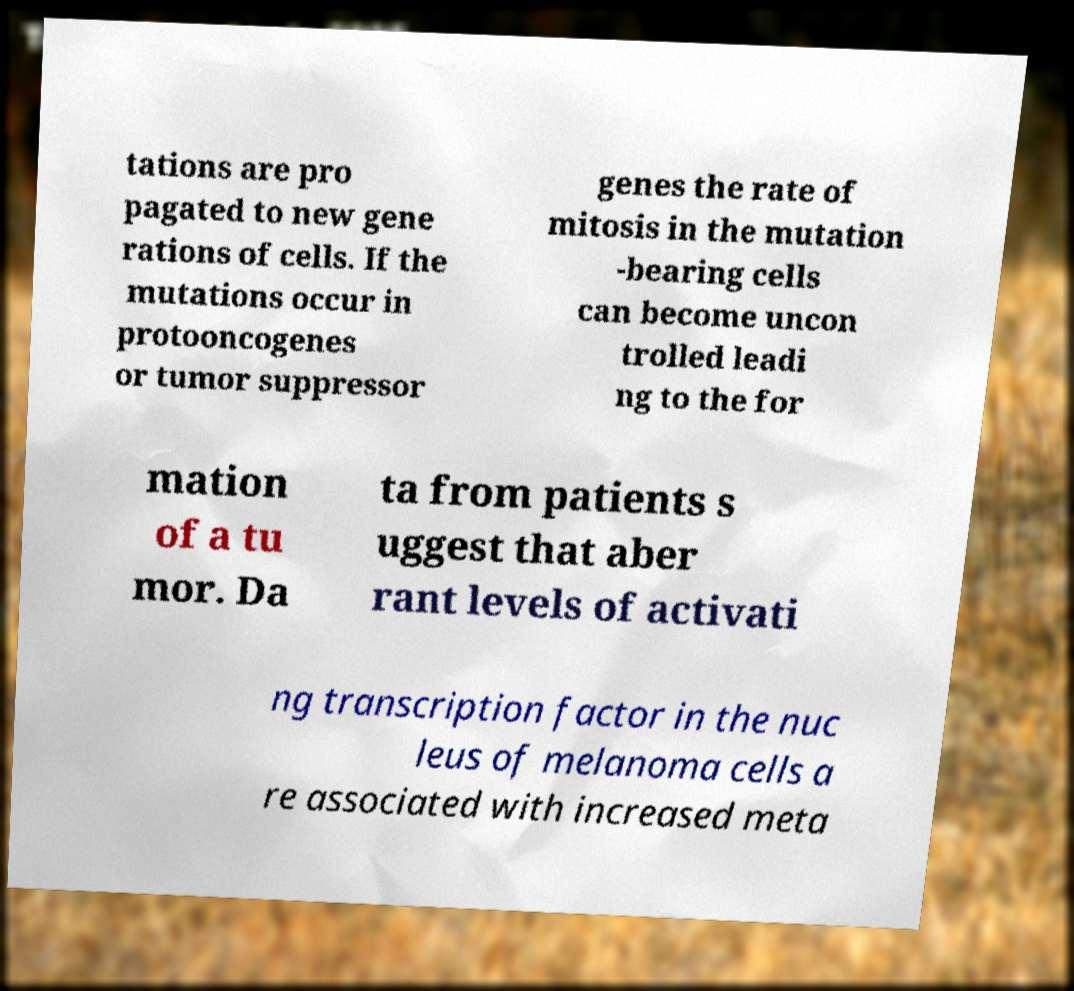Please identify and transcribe the text found in this image. tations are pro pagated to new gene rations of cells. If the mutations occur in protooncogenes or tumor suppressor genes the rate of mitosis in the mutation -bearing cells can become uncon trolled leadi ng to the for mation of a tu mor. Da ta from patients s uggest that aber rant levels of activati ng transcription factor in the nuc leus of melanoma cells a re associated with increased meta 